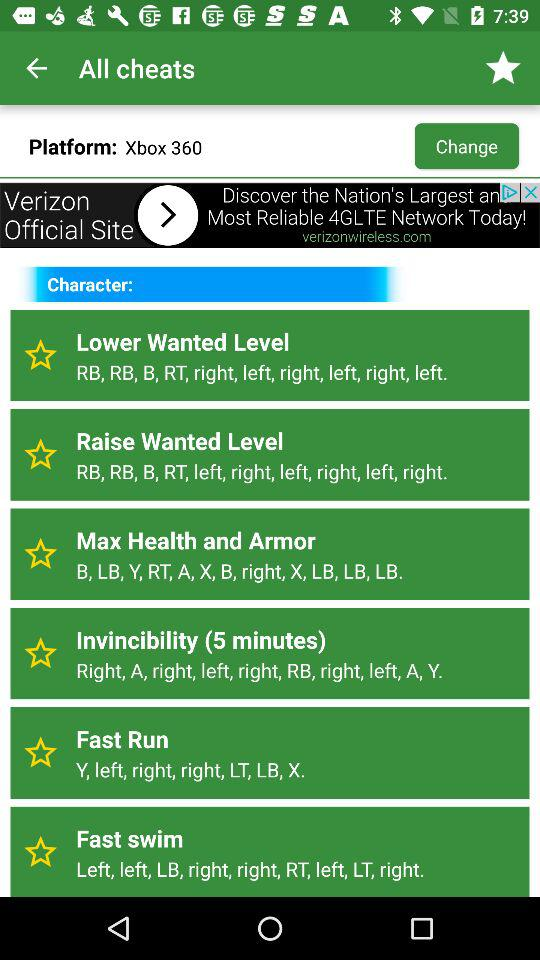Which cheat option is applicable for five minutes? The cheat option that is applicable for five minutes is "Invincibility". 